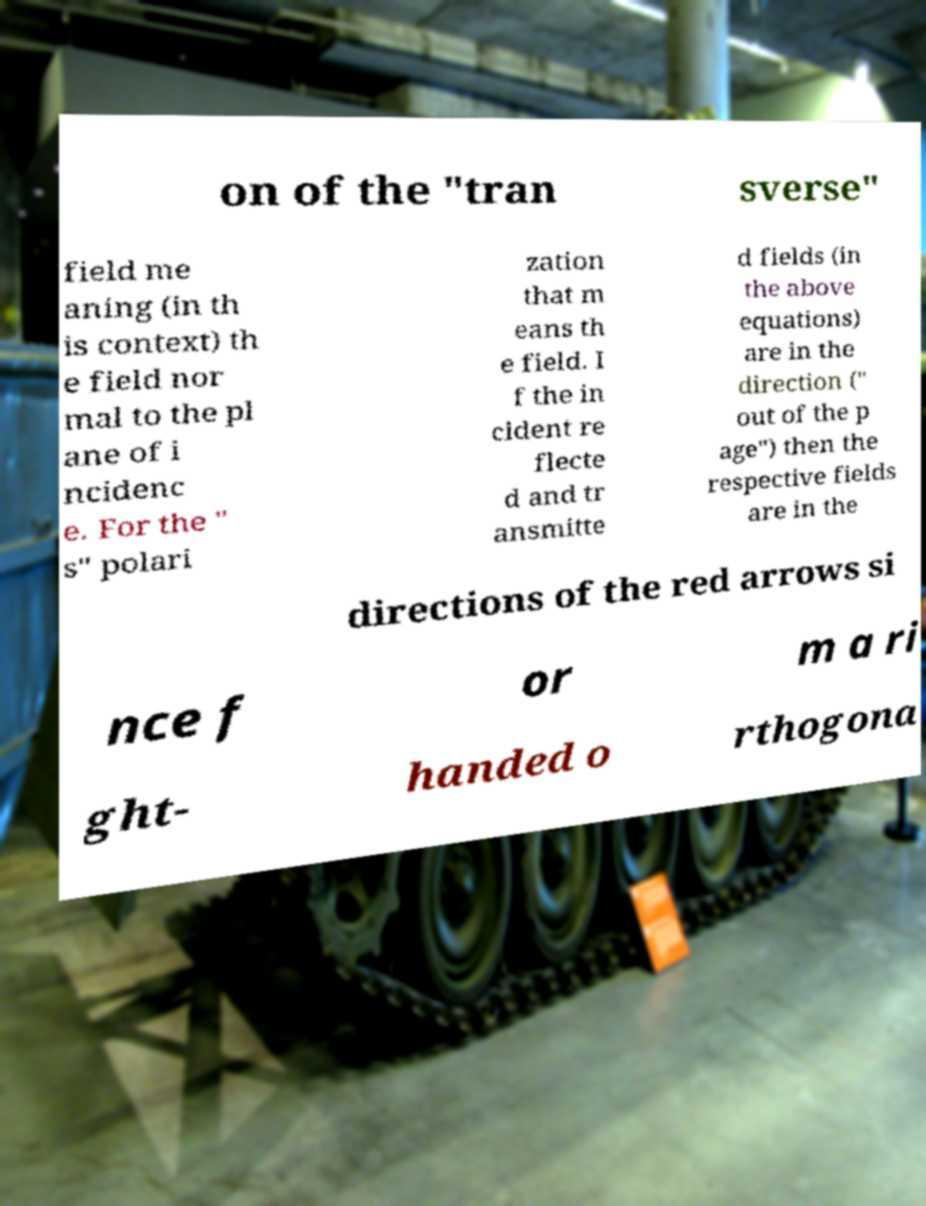For documentation purposes, I need the text within this image transcribed. Could you provide that? on of the "tran sverse" field me aning (in th is context) th e field nor mal to the pl ane of i ncidenc e. For the " s" polari zation that m eans th e field. I f the in cident re flecte d and tr ansmitte d fields (in the above equations) are in the direction (" out of the p age") then the respective fields are in the directions of the red arrows si nce f or m a ri ght- handed o rthogona 